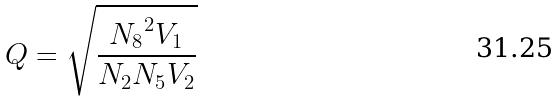<formula> <loc_0><loc_0><loc_500><loc_500>Q = \sqrt { \frac { { N _ { 8 } } ^ { 2 } V _ { 1 } } { N _ { 2 } N _ { 5 } V _ { 2 } } }</formula> 